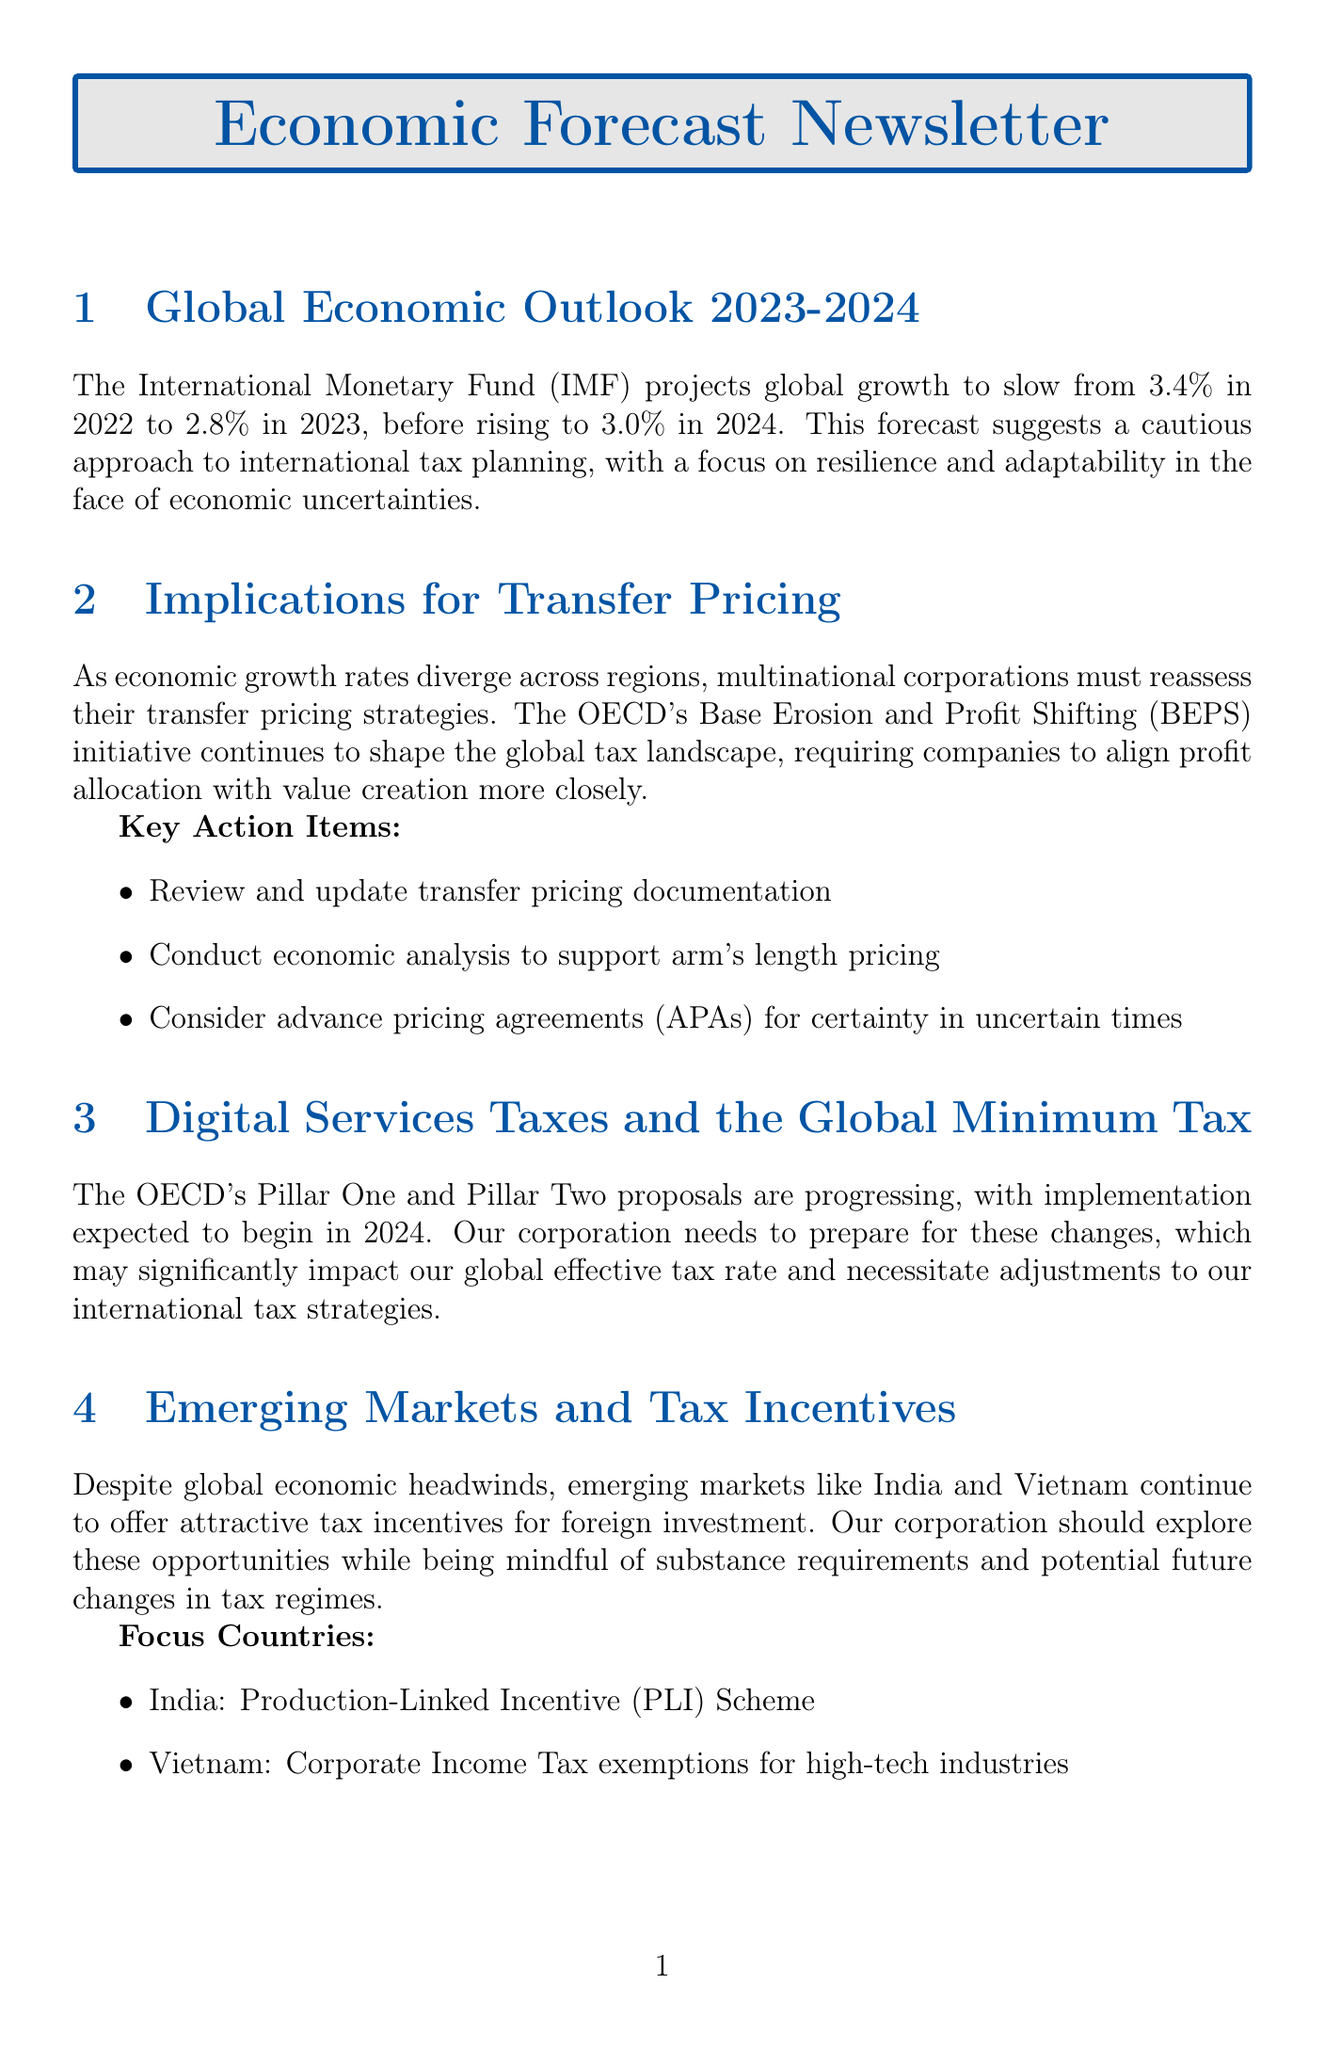What is the global growth projection for 2023? According to the IMF, the global growth projection for 2023 is 2.8%.
Answer: 2.8% What is the main focus for multinational corporations concerning transfer pricing? The main focus for multinational corporations is to align profit allocation with value creation more closely.
Answer: Value creation What is the expected implementation year for OECD's Pillar One and Pillar Two proposals? The expected implementation year for these proposals is 2024.
Answer: 2024 Which emerging market offers the Production-Linked Incentive Scheme? The emerging market that offers the Production-Linked Incentive Scheme is India.
Answer: India What is the recommended tax technology solution mentioned in the document? One of the recommended tax technology solutions is SAP Tax Compliance.
Answer: SAP Tax Compliance How much potential annual revenue is expected globally from the 15% minimum tax rate? The potential annual revenue expected globally from the 15% minimum tax rate is $150 billion.
Answer: $150 billion What should be reviewed and updated according to the implications for transfer pricing? The document suggests reviewing and updating transfer pricing documentation.
Answer: Transfer pricing documentation What is one key consideration for aligning tax planning with ESG goals? One key consideration for aligning tax planning with ESG goals is tax transparency reporting.
Answer: Tax transparency reporting What significant challenge do multinational corporations face in the current economic climate? The significant challenge faced by multinational corporations is economic uncertainties.
Answer: Economic uncertainties 